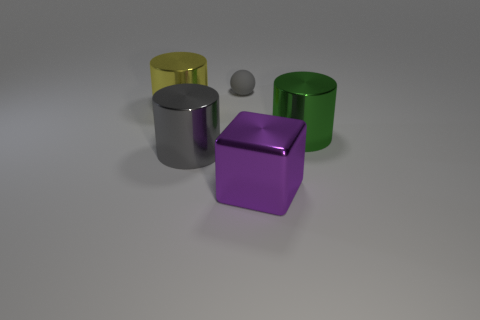Subtract all big gray cylinders. How many cylinders are left? 2 Add 3 yellow cylinders. How many objects exist? 8 Subtract all green cylinders. How many cylinders are left? 2 Subtract 1 spheres. How many spheres are left? 0 Subtract all green metal objects. Subtract all big gray shiny cylinders. How many objects are left? 3 Add 4 big shiny things. How many big shiny things are left? 8 Add 1 tiny red metal spheres. How many tiny red metal spheres exist? 1 Subtract 1 gray cylinders. How many objects are left? 4 Subtract all blocks. How many objects are left? 4 Subtract all red cylinders. Subtract all green blocks. How many cylinders are left? 3 